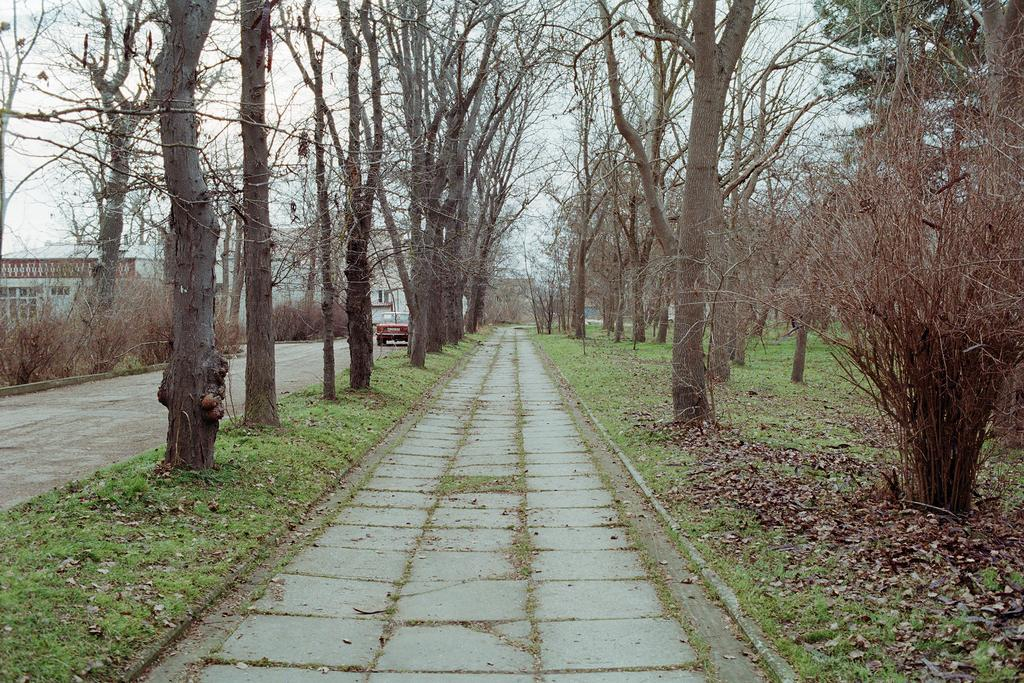What type of vegetation can be seen in the image? There are trees in the image. What structures are located on the left side of the image? There are buildings on the left side of the image. What is moving on the road in the image? There is a vehicle on the road in the image. What is the condition of the sky in the image? The sky is cloudy in the image. Can you see a needle in the image? No, there is no needle present in the image. What type of pie is being served in the image? There is no pie present in the image. 